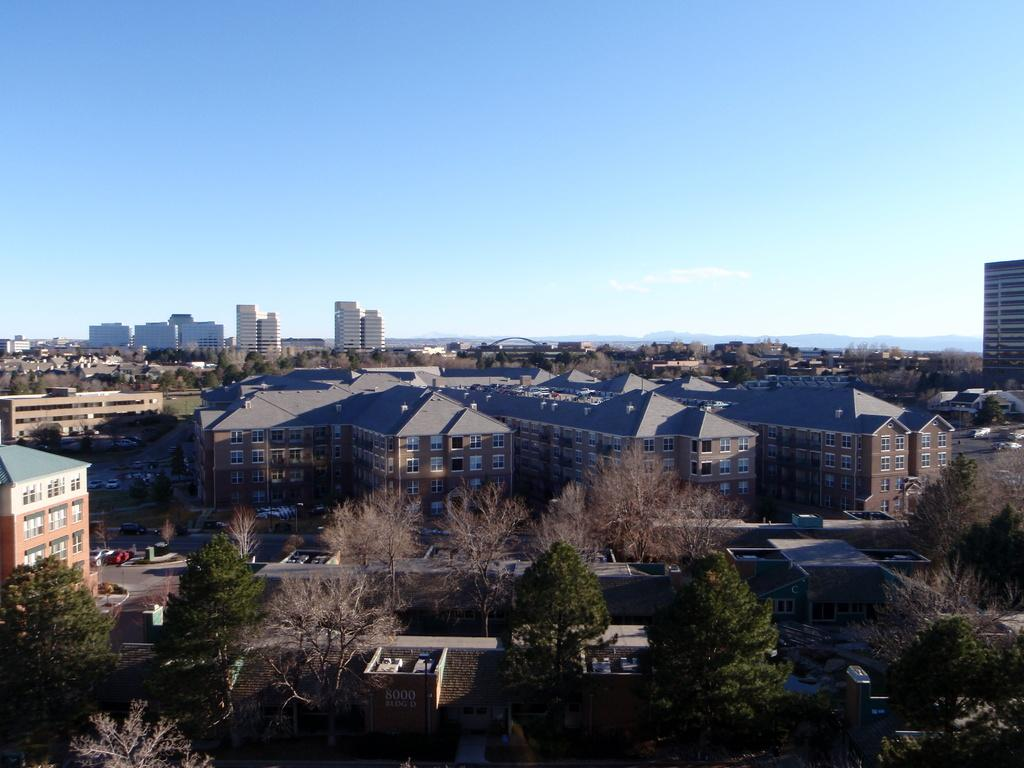What type of view is provided by the image? The image provides an aerial view of a certain area. What structures can be seen in the area? There are houses in the area. What type of vegetation is present in the area? There are trees in the area. What type of transportation infrastructure is present in the area? There are streets and a road in the area. What is visible in the background of the image? The sky is clear and visible in the background of the image. What type of lace can be seen decorating the houses in the image? There is no lace visible on the houses in the image. How many frogs can be seen hopping along the streets in the image? There are no frogs present in the image. 